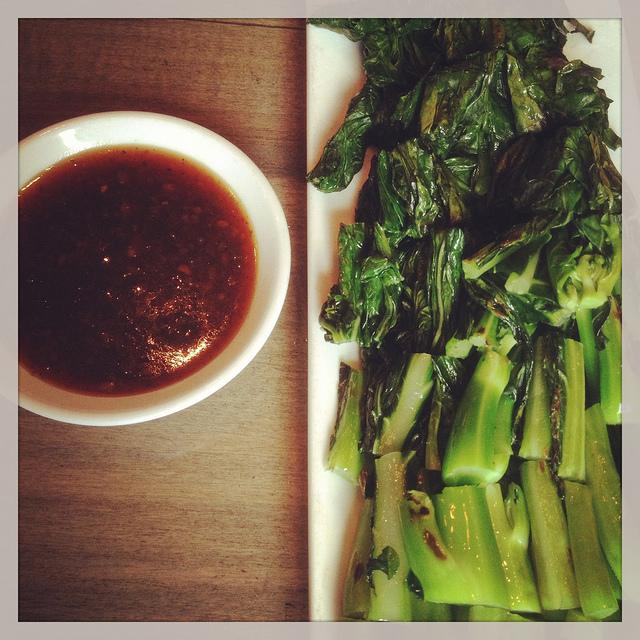What is about to be dipped? Please explain your reasoning. broccoli. There are no people on the table. the food items are green and are not dunkaroos or cheese. 